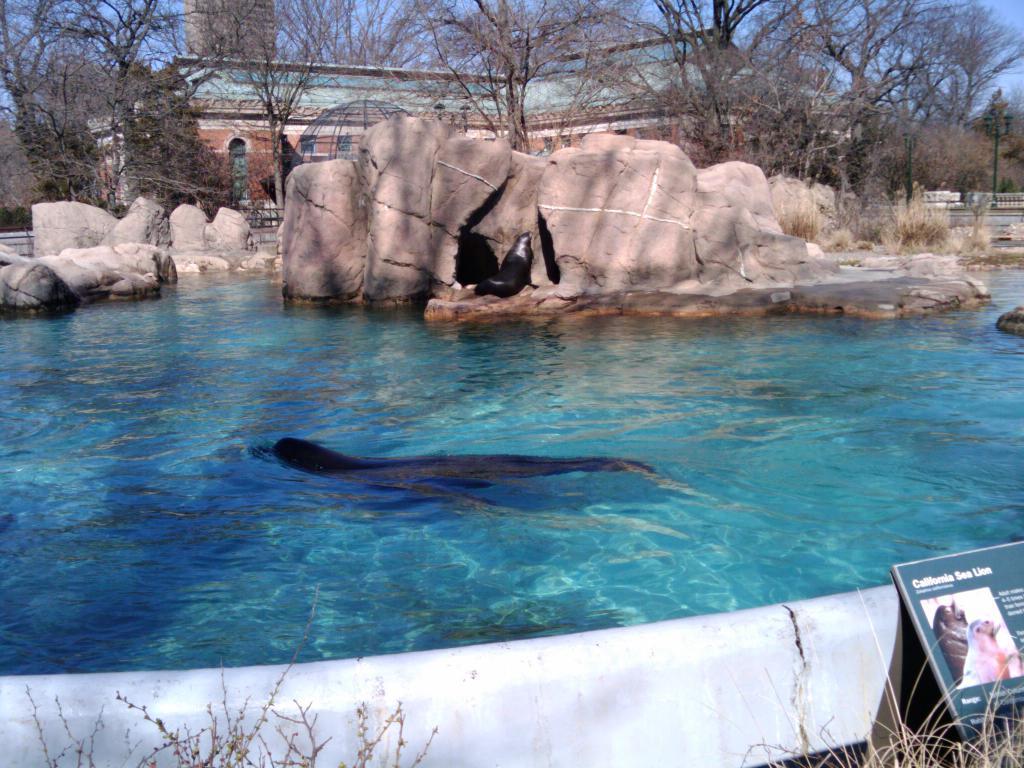Could you give a brief overview of what you see in this image? In this water seals are swimming, there are trees at here and here it looks like a house. In the right side there is an image of these seals. 